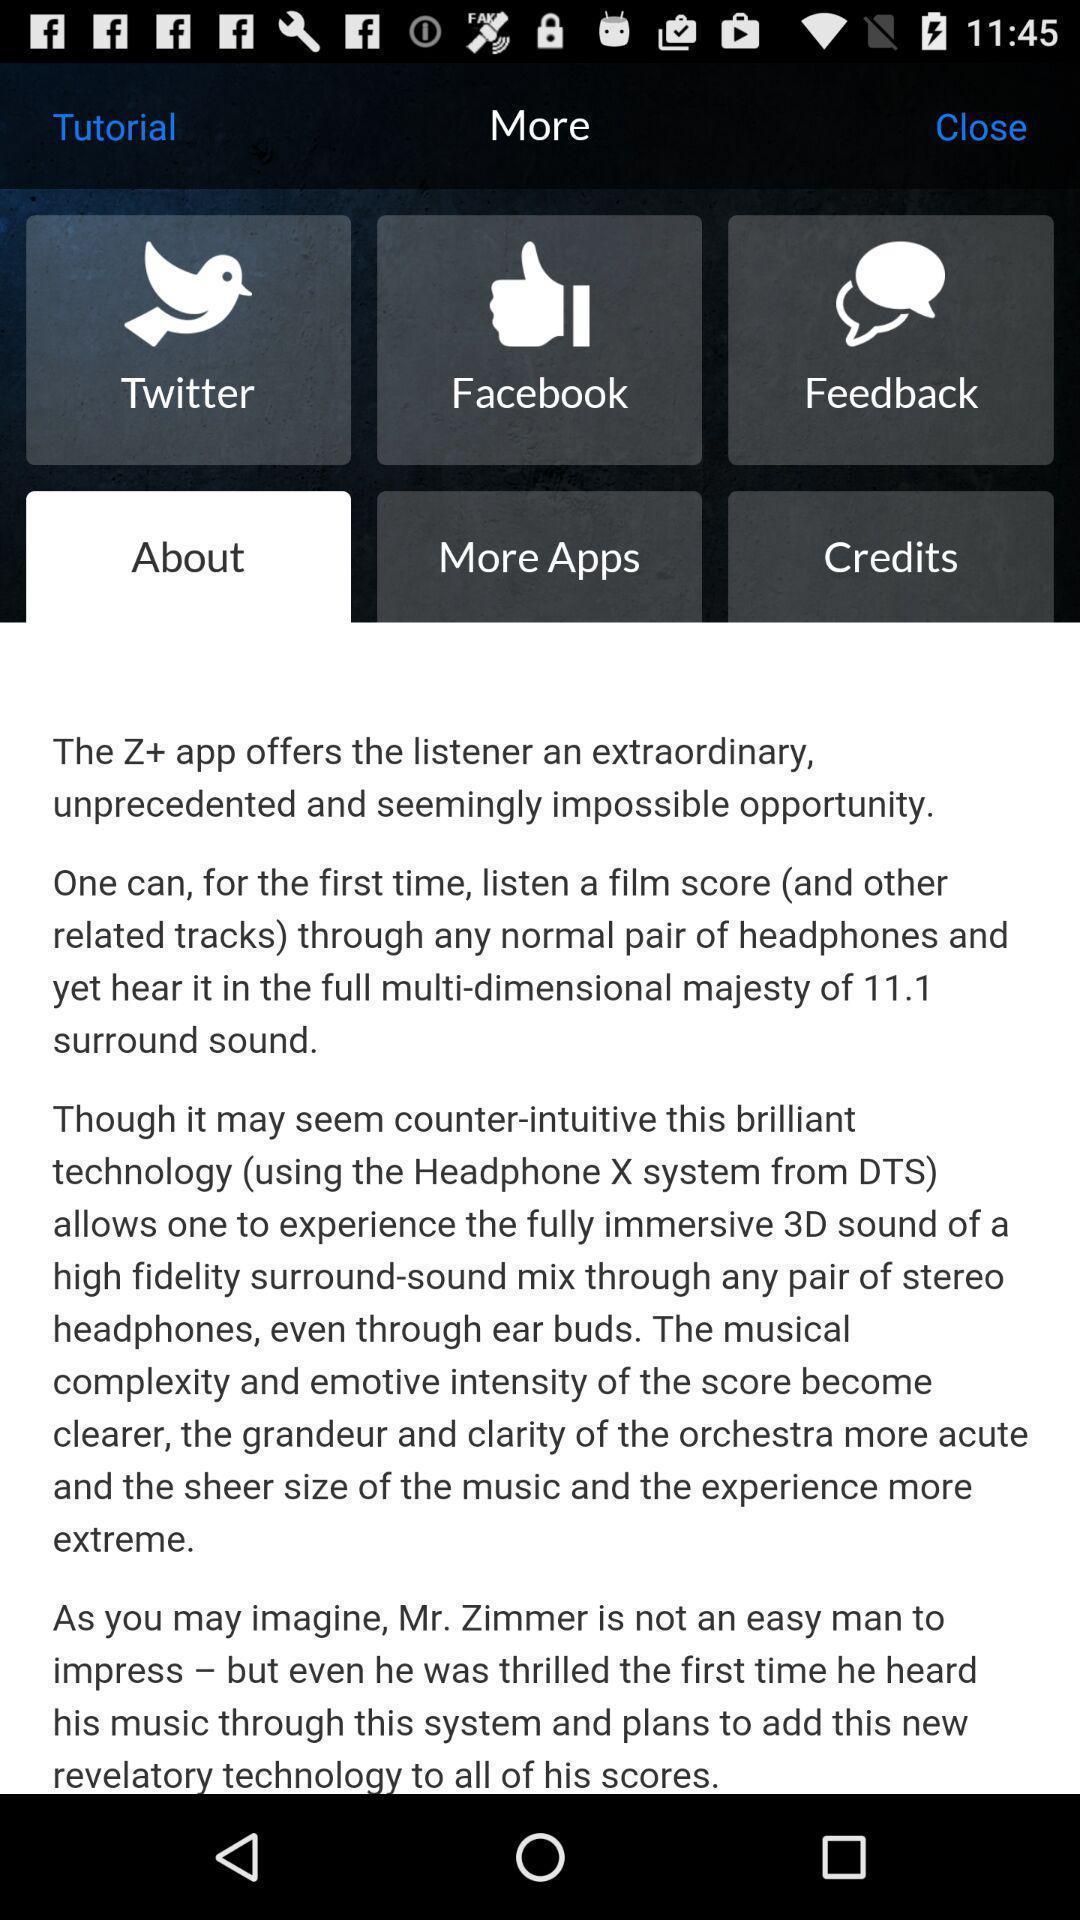Give me a summary of this screen capture. Screen showing about. 